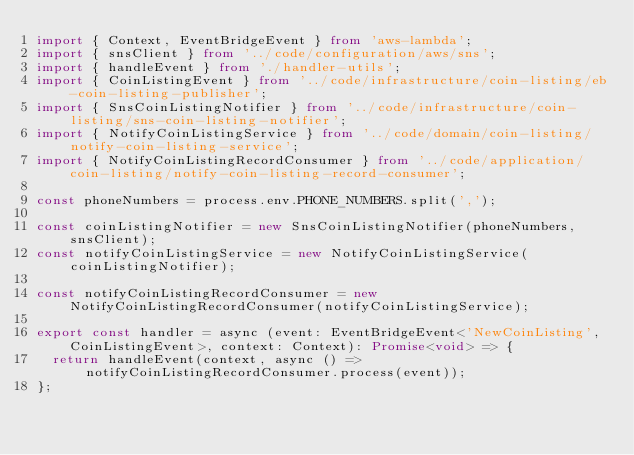Convert code to text. <code><loc_0><loc_0><loc_500><loc_500><_TypeScript_>import { Context, EventBridgeEvent } from 'aws-lambda';
import { snsClient } from '../code/configuration/aws/sns';
import { handleEvent } from './handler-utils';
import { CoinListingEvent } from '../code/infrastructure/coin-listing/eb-coin-listing-publisher';
import { SnsCoinListingNotifier } from '../code/infrastructure/coin-listing/sns-coin-listing-notifier';
import { NotifyCoinListingService } from '../code/domain/coin-listing/notify-coin-listing-service';
import { NotifyCoinListingRecordConsumer } from '../code/application/coin-listing/notify-coin-listing-record-consumer';

const phoneNumbers = process.env.PHONE_NUMBERS.split(',');

const coinListingNotifier = new SnsCoinListingNotifier(phoneNumbers, snsClient);
const notifyCoinListingService = new NotifyCoinListingService(coinListingNotifier);

const notifyCoinListingRecordConsumer = new NotifyCoinListingRecordConsumer(notifyCoinListingService);

export const handler = async (event: EventBridgeEvent<'NewCoinListing', CoinListingEvent>, context: Context): Promise<void> => {
  return handleEvent(context, async () => notifyCoinListingRecordConsumer.process(event));
};
</code> 